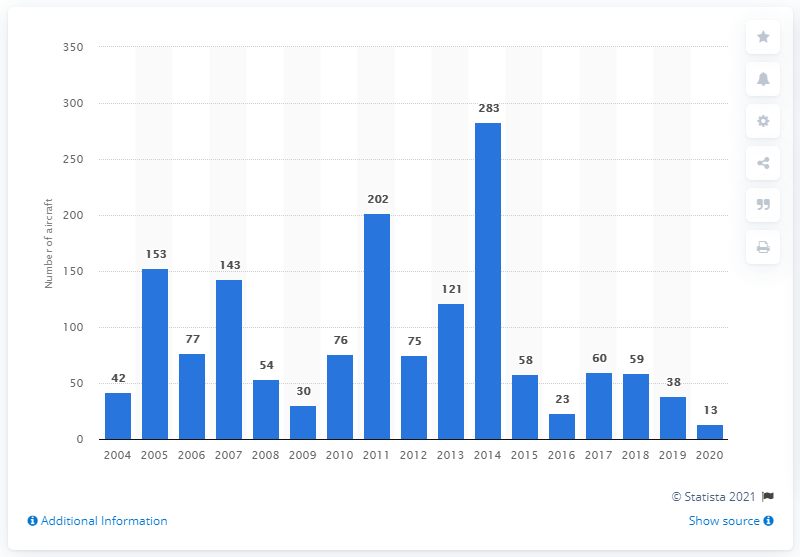Give some essential details in this illustration. Boeing received 13 orders for their 777 model aircraft in 2020. 